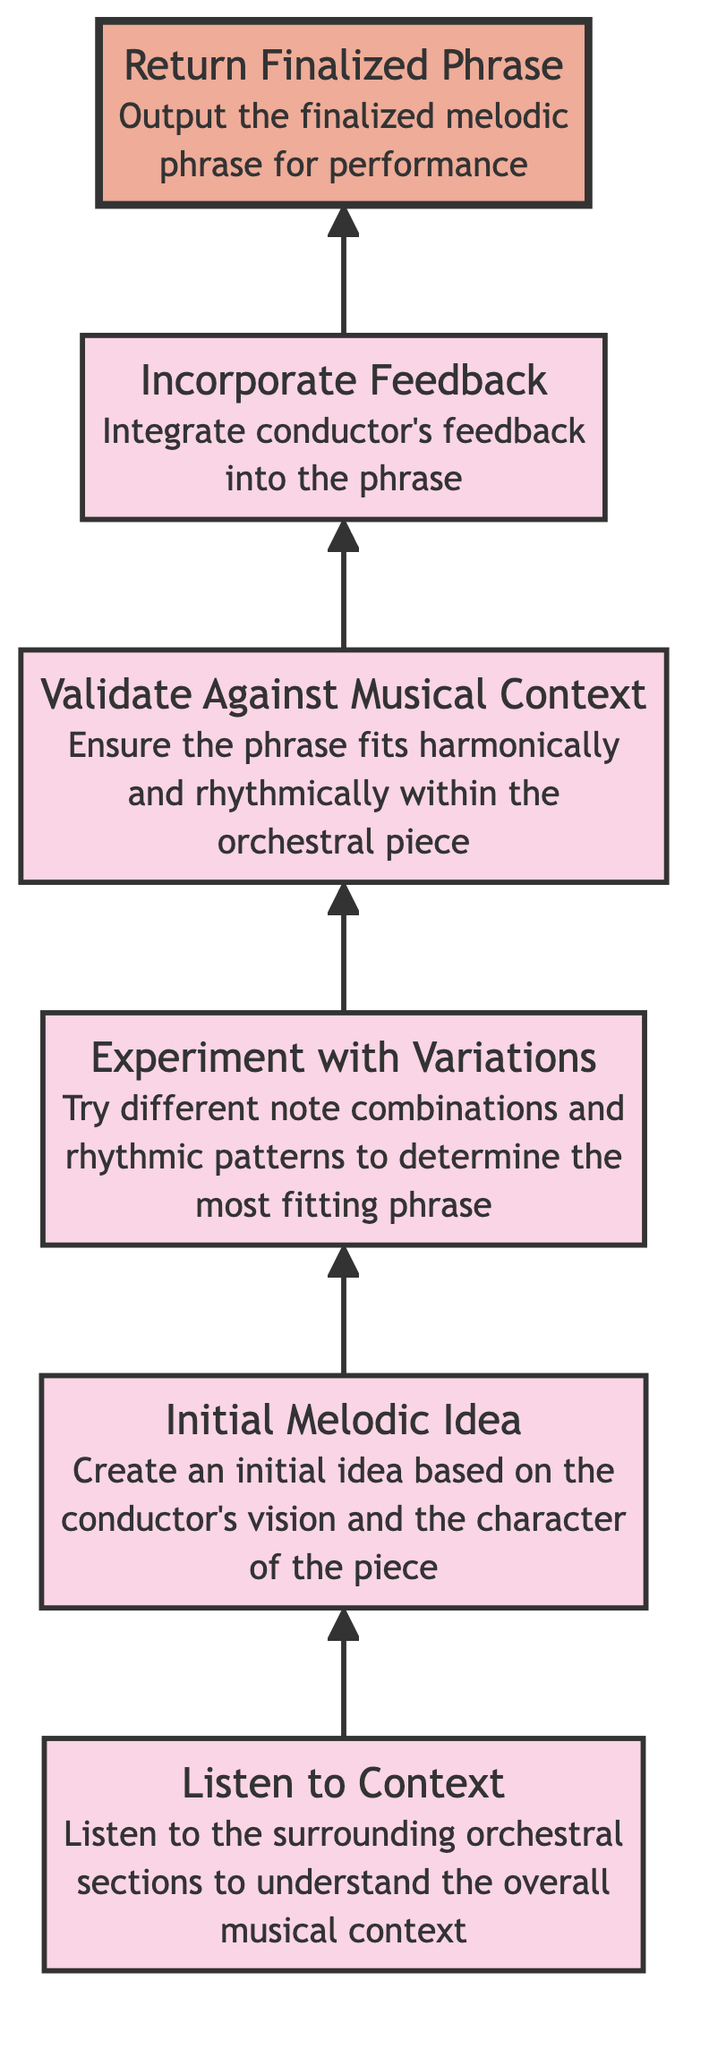What is the first step in the flowchart? The first step is "Listen to Context," which means paying attention to the surrounding orchestral sections to grasp the overall musical context before starting the improvisation process.
Answer: Listen to Context How many elements are there in the flowchart? The flowchart comprises six distinct elements, each representing a step in the process of improvising melodic phrases on the violin.
Answer: 6 What is the last step before finalizing the phrase? The last step before the finalized phrase is "Incorporate Feedback," which requires integrating the conductor's feedback into the improvised melodic phrase to align it with the ensemble's expectations.
Answer: Incorporate Feedback Which step involves ensuring harmonical and rhythmical fitting? The step that involves ensuring the phrase fits harmonically and rhythmically is "Validate Against Musical Context," as it checks that the created phrase complements the orchestral piece.
Answer: Validate Against Musical Context What do you create in the "Initial Melodic Idea" step? In the "Initial Melodic Idea" step, the goal is to create an initial idea based on the conductor's vision and the character of the piece being performed, serving as the foundation for improvisation.
Answer: Initial Melodic Idea Which element is highlighted in the flowchart? The highlighted element in the flowchart, which indicates its significance in the process of improvisation, is "Return Finalized Phrase," emphasizing the importance of producing a completed melodic phrase for the performance.
Answer: Return Finalized Phrase After experimenting with variations, what is the next step? After "Experiment with Variations," the next step is to "Validate Against Musical Context," ensuring that the experimented melodic phrases work within the orchestral framework before finalizing any ideas.
Answer: Validate Against Musical Context How does the diagram show sequential progression? The diagram illustrates the sequential progression by connecting each element with arrows that indicate the flow of the improvisational process from the initial steps to the final output, culminating in the finalized phrase for performance.
Answer: Arrows connecting elements 